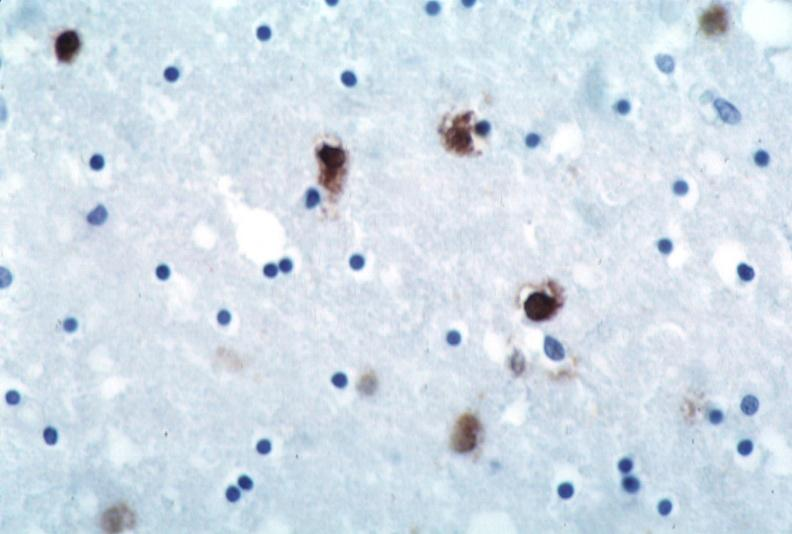what is present?
Answer the question using a single word or phrase. Nervous 